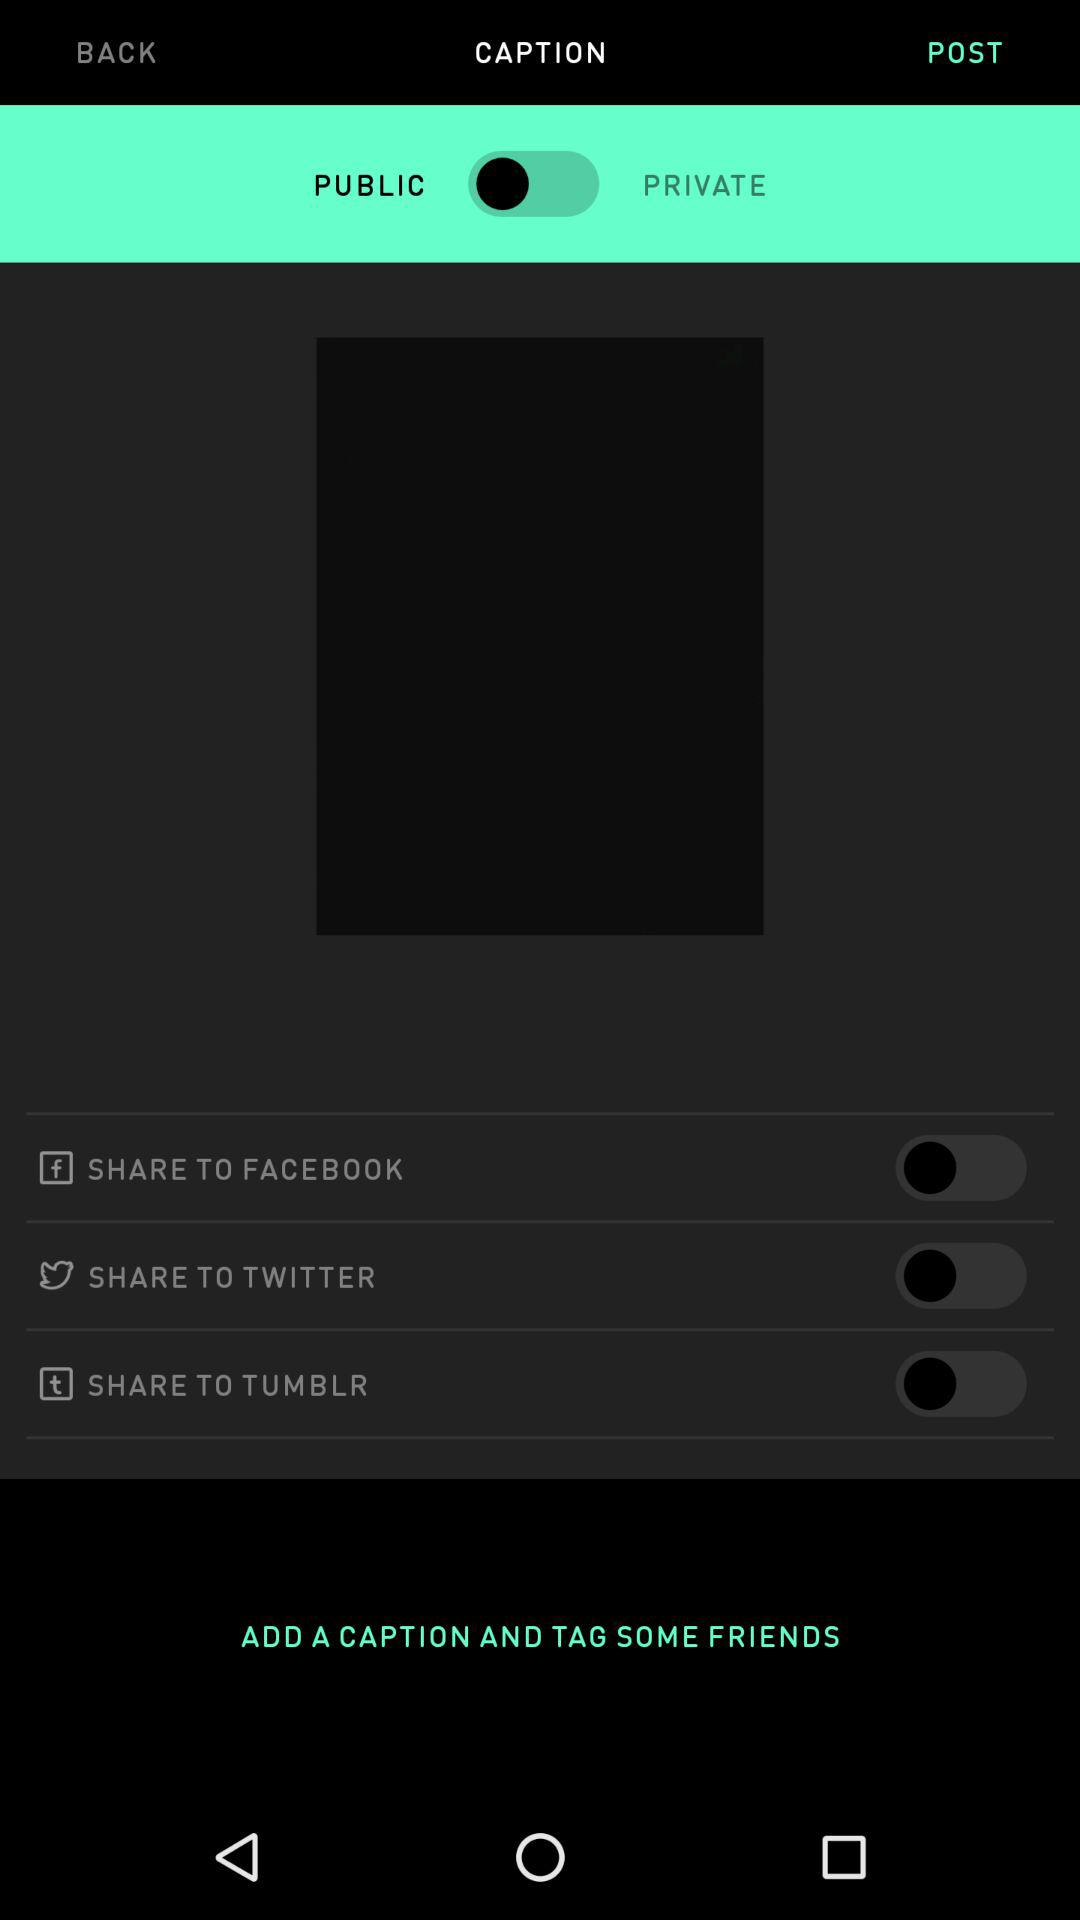What are the sharing options? The sharing options are "FACEBOOK", "TWITTER" and "TUMBLR". 